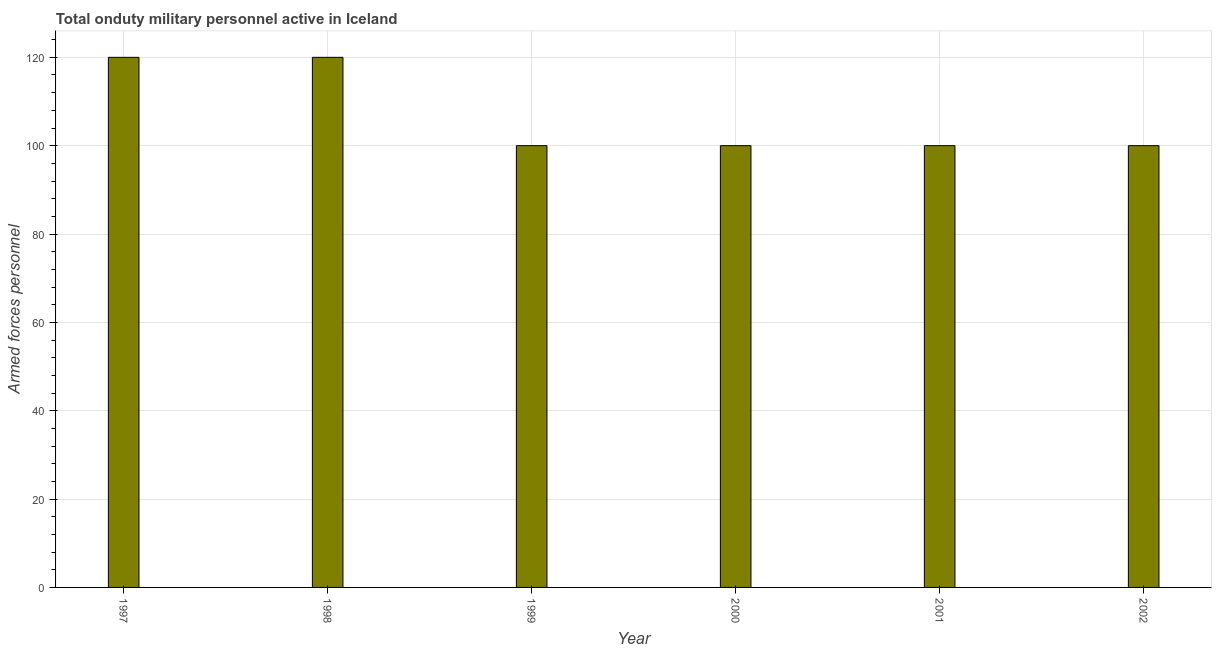Does the graph contain grids?
Ensure brevity in your answer.  Yes. What is the title of the graph?
Your response must be concise. Total onduty military personnel active in Iceland. What is the label or title of the X-axis?
Provide a short and direct response. Year. What is the label or title of the Y-axis?
Give a very brief answer. Armed forces personnel. Across all years, what is the maximum number of armed forces personnel?
Your answer should be compact. 120. Across all years, what is the minimum number of armed forces personnel?
Offer a very short reply. 100. In which year was the number of armed forces personnel maximum?
Your answer should be very brief. 1997. What is the sum of the number of armed forces personnel?
Keep it short and to the point. 640. What is the average number of armed forces personnel per year?
Give a very brief answer. 106. Do a majority of the years between 2000 and 1997 (inclusive) have number of armed forces personnel greater than 96 ?
Offer a terse response. Yes. What is the ratio of the number of armed forces personnel in 1997 to that in 2001?
Make the answer very short. 1.2. Is the number of armed forces personnel in 1998 less than that in 1999?
Provide a short and direct response. No. In how many years, is the number of armed forces personnel greater than the average number of armed forces personnel taken over all years?
Your response must be concise. 2. Are all the bars in the graph horizontal?
Make the answer very short. No. What is the difference between two consecutive major ticks on the Y-axis?
Offer a very short reply. 20. Are the values on the major ticks of Y-axis written in scientific E-notation?
Give a very brief answer. No. What is the Armed forces personnel of 1997?
Provide a succinct answer. 120. What is the Armed forces personnel in 1998?
Provide a short and direct response. 120. What is the Armed forces personnel in 1999?
Your response must be concise. 100. What is the Armed forces personnel in 2001?
Keep it short and to the point. 100. What is the Armed forces personnel in 2002?
Your response must be concise. 100. What is the difference between the Armed forces personnel in 1997 and 1998?
Give a very brief answer. 0. What is the difference between the Armed forces personnel in 1997 and 1999?
Your answer should be very brief. 20. What is the difference between the Armed forces personnel in 1997 and 2000?
Offer a terse response. 20. What is the difference between the Armed forces personnel in 1997 and 2002?
Offer a terse response. 20. What is the difference between the Armed forces personnel in 1998 and 1999?
Offer a very short reply. 20. What is the difference between the Armed forces personnel in 1998 and 2001?
Offer a very short reply. 20. What is the difference between the Armed forces personnel in 1999 and 2002?
Provide a succinct answer. 0. What is the difference between the Armed forces personnel in 2000 and 2001?
Your response must be concise. 0. What is the difference between the Armed forces personnel in 2000 and 2002?
Ensure brevity in your answer.  0. What is the difference between the Armed forces personnel in 2001 and 2002?
Give a very brief answer. 0. What is the ratio of the Armed forces personnel in 1997 to that in 1999?
Ensure brevity in your answer.  1.2. What is the ratio of the Armed forces personnel in 1997 to that in 2000?
Make the answer very short. 1.2. What is the ratio of the Armed forces personnel in 1997 to that in 2001?
Keep it short and to the point. 1.2. What is the ratio of the Armed forces personnel in 1997 to that in 2002?
Provide a short and direct response. 1.2. What is the ratio of the Armed forces personnel in 1998 to that in 1999?
Offer a terse response. 1.2. What is the ratio of the Armed forces personnel in 1998 to that in 2002?
Keep it short and to the point. 1.2. What is the ratio of the Armed forces personnel in 1999 to that in 2000?
Make the answer very short. 1. What is the ratio of the Armed forces personnel in 1999 to that in 2001?
Keep it short and to the point. 1. What is the ratio of the Armed forces personnel in 1999 to that in 2002?
Ensure brevity in your answer.  1. What is the ratio of the Armed forces personnel in 2001 to that in 2002?
Your answer should be very brief. 1. 